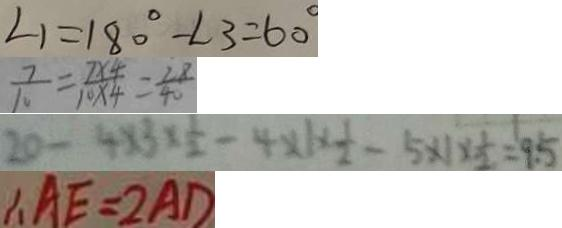<formula> <loc_0><loc_0><loc_500><loc_500>\angle 1 = 1 8 0 ^ { \circ } - \angle 3 = 6 0 ^ { \circ } 
 \frac { 7 } { 1 0 } = \frac { 7 \times 4 } { 1 0 \times 4 } = \frac { 2 8 } { 4 0 } 
 2 0 - 4 \times 3 \times \frac { 1 } { 2 } - 4 \times 1 \times \frac { 1 } { 2 } - 5 \times 1 \times \frac { 1 } { 2 } = 9 . 5 
 \therefore A E = 2 A D</formula> 